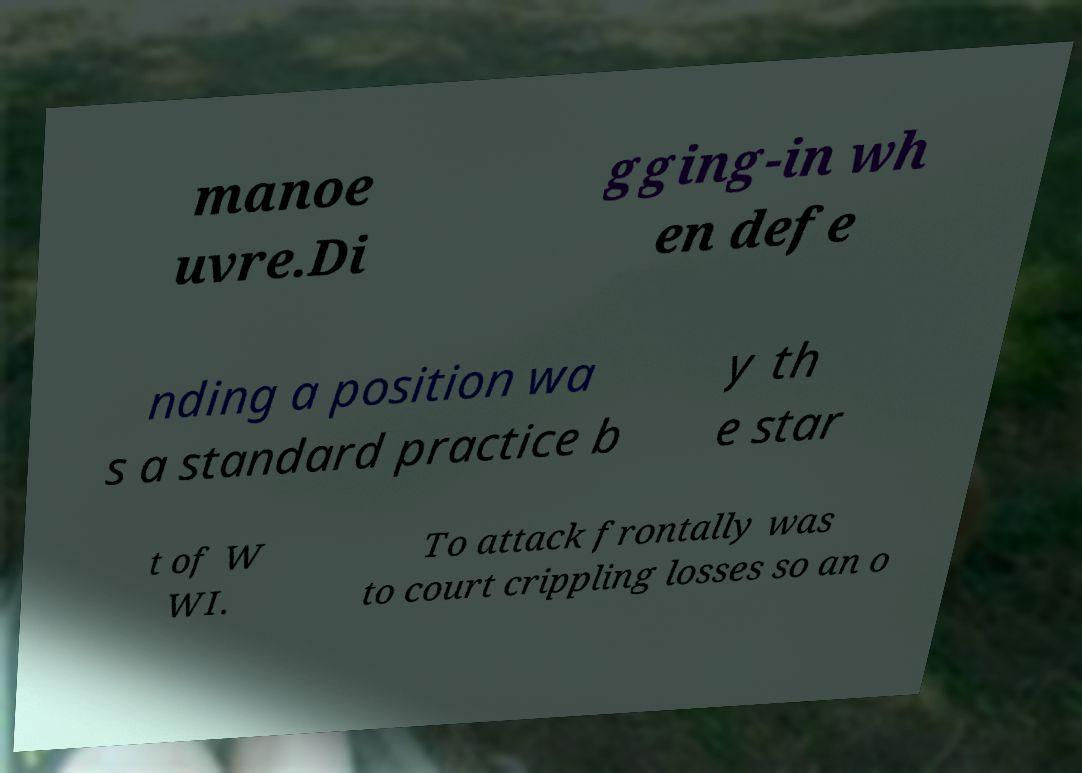Could you assist in decoding the text presented in this image and type it out clearly? manoe uvre.Di gging-in wh en defe nding a position wa s a standard practice b y th e star t of W WI. To attack frontally was to court crippling losses so an o 